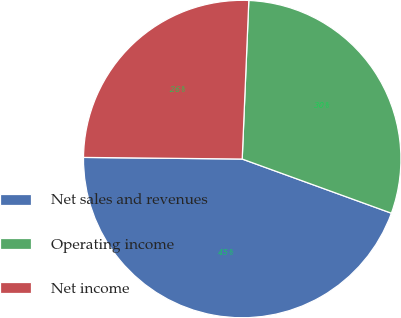<chart> <loc_0><loc_0><loc_500><loc_500><pie_chart><fcel>Net sales and revenues<fcel>Operating income<fcel>Net income<nl><fcel>44.62%<fcel>29.88%<fcel>25.5%<nl></chart> 